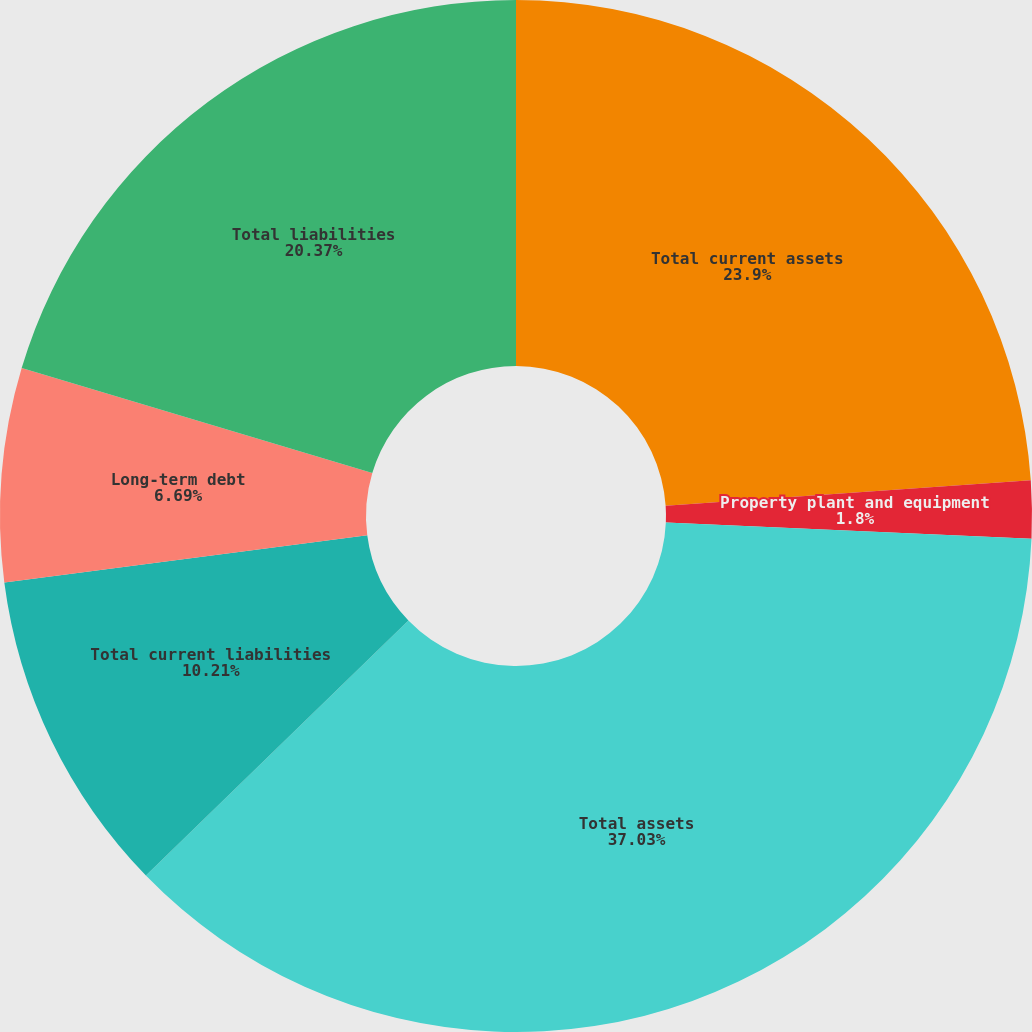Convert chart to OTSL. <chart><loc_0><loc_0><loc_500><loc_500><pie_chart><fcel>Total current assets<fcel>Property plant and equipment<fcel>Total assets<fcel>Total current liabilities<fcel>Long-term debt<fcel>Total liabilities<nl><fcel>23.9%<fcel>1.8%<fcel>37.03%<fcel>10.21%<fcel>6.69%<fcel>20.37%<nl></chart> 